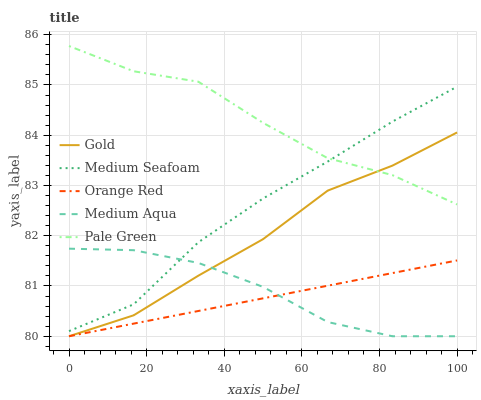Does Orange Red have the minimum area under the curve?
Answer yes or no. Yes. Does Pale Green have the maximum area under the curve?
Answer yes or no. Yes. Does Medium Aqua have the minimum area under the curve?
Answer yes or no. No. Does Medium Aqua have the maximum area under the curve?
Answer yes or no. No. Is Orange Red the smoothest?
Answer yes or no. Yes. Is Pale Green the roughest?
Answer yes or no. Yes. Is Medium Aqua the smoothest?
Answer yes or no. No. Is Medium Aqua the roughest?
Answer yes or no. No. Does Medium Aqua have the lowest value?
Answer yes or no. Yes. Does Medium Seafoam have the lowest value?
Answer yes or no. No. Does Pale Green have the highest value?
Answer yes or no. Yes. Does Medium Aqua have the highest value?
Answer yes or no. No. Is Orange Red less than Medium Seafoam?
Answer yes or no. Yes. Is Medium Seafoam greater than Orange Red?
Answer yes or no. Yes. Does Orange Red intersect Medium Aqua?
Answer yes or no. Yes. Is Orange Red less than Medium Aqua?
Answer yes or no. No. Is Orange Red greater than Medium Aqua?
Answer yes or no. No. Does Orange Red intersect Medium Seafoam?
Answer yes or no. No. 